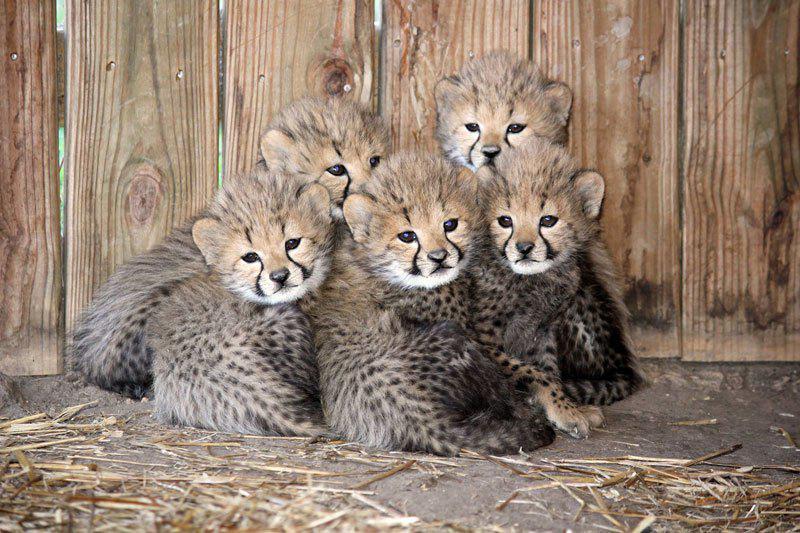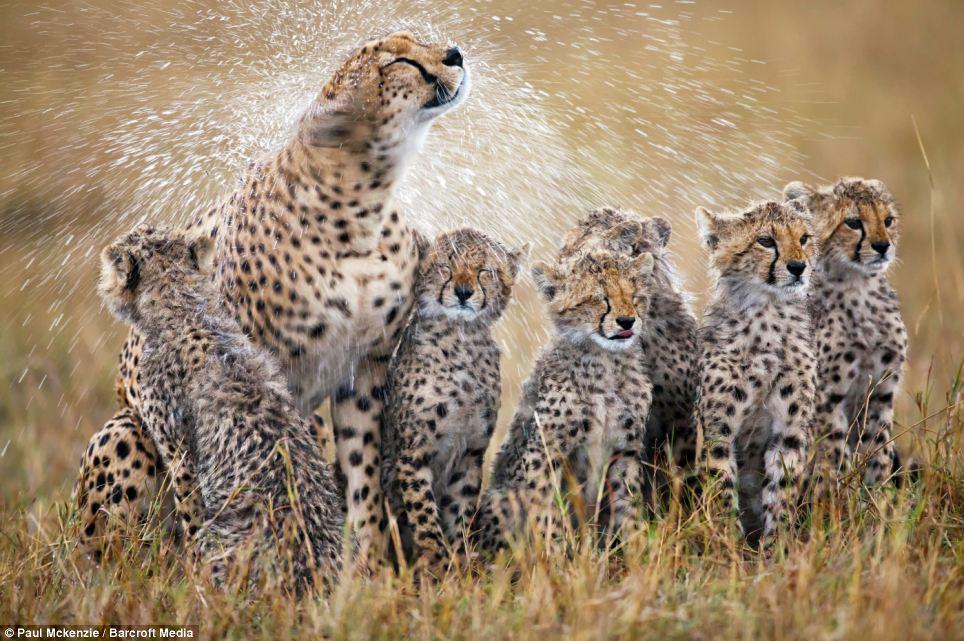The first image is the image on the left, the second image is the image on the right. Analyze the images presented: Is the assertion "There are 4 cheetas in the field." valid? Answer yes or no. No. 